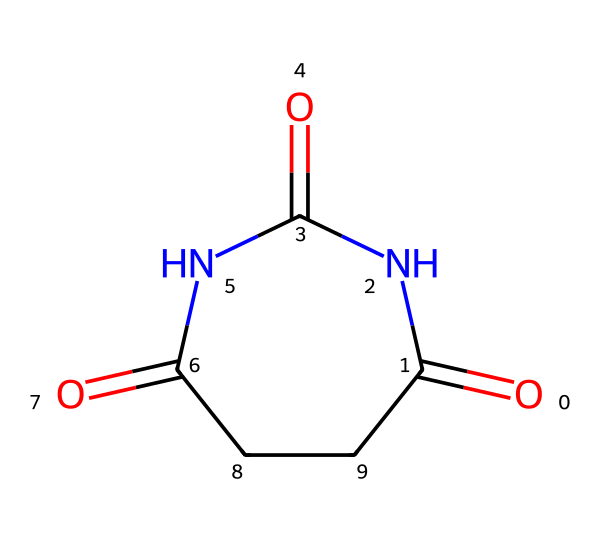What is the total number of nitrogen atoms in this chemical? By examining the SMILES representation, we can identify the atoms specified in the structure. The nitrogen atoms are represented by "N". Counting these in the structure, there are two nitrogen atoms present in the ring.
Answer: 2 What is the number of carbon atoms in the molecule? In the provided SMILES, each "C" represents a carbon atom. There are four carbon atoms visible when counting the "C" directly and the ones participating in the ring structure within the molecular framework.
Answer: 4 What type of structure does this compound represent? The SMILES indicates the presence of an "N" (nitrogen) atom connected to carbonyl groups (C=O). The presence of these features within the same molecule classifies it as an imide, which contains nitrogen and carbonyl functional groups.
Answer: imide How many double bonds are present in this molecule? The double bonds in the molecule are indicated by "=", which connects carbon to oxygen. By identifying those in the SMILES, we find three double bonds: two C=O and one C=N, resulting in a total count.
Answer: 3 What is the functional group visible in this chemical? By recognizing the distinct CO and N patterns in the SMILES representation, you can identify that the functional groups represented include carbonyl (C=O) and the imide functional group itself, characterized by its cyclic structure.
Answer: carbonyl What is the molecular formula of this compound? To deduce the molecular formula, we count the numbers of each type of atom present from the SMILES: 4 carbon atoms (C), 4 nitrogen atoms (N), and 6 oxygen atoms (O). Thus, the molecular formula derived from this count is C4H4N4O3.
Answer: C4H4N4O3 